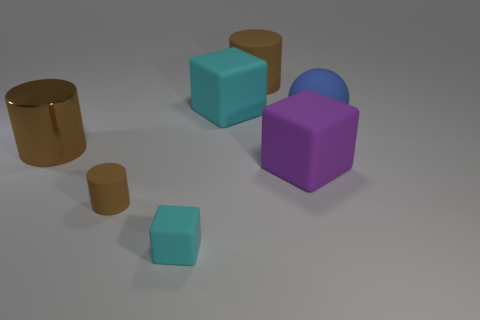What might be the purpose of such an arrangement, hypothetically speaking? Hypothetically, this arrangement of shapes could serve several purposes. It could be a visual study in form and color, exploring how different shapes relate to each other within a space. It might also be an exercise in 3D modeling, allowing an artist or designer to demonstrate proficiency with creating and rendering basic geometric forms. Alternatively, it could be a conceptual art piece, inviting the viewer to interpret the relationships between the objects and the empty space surrounding them. 